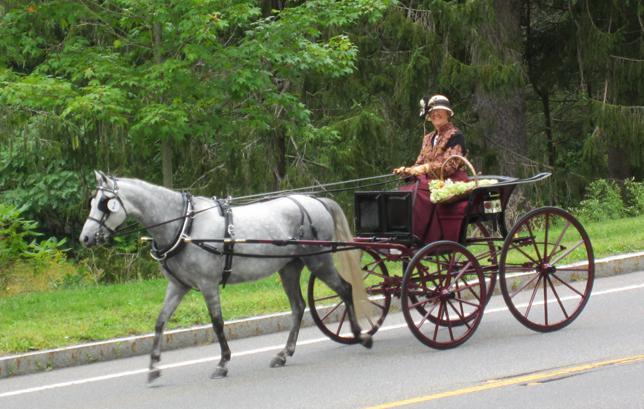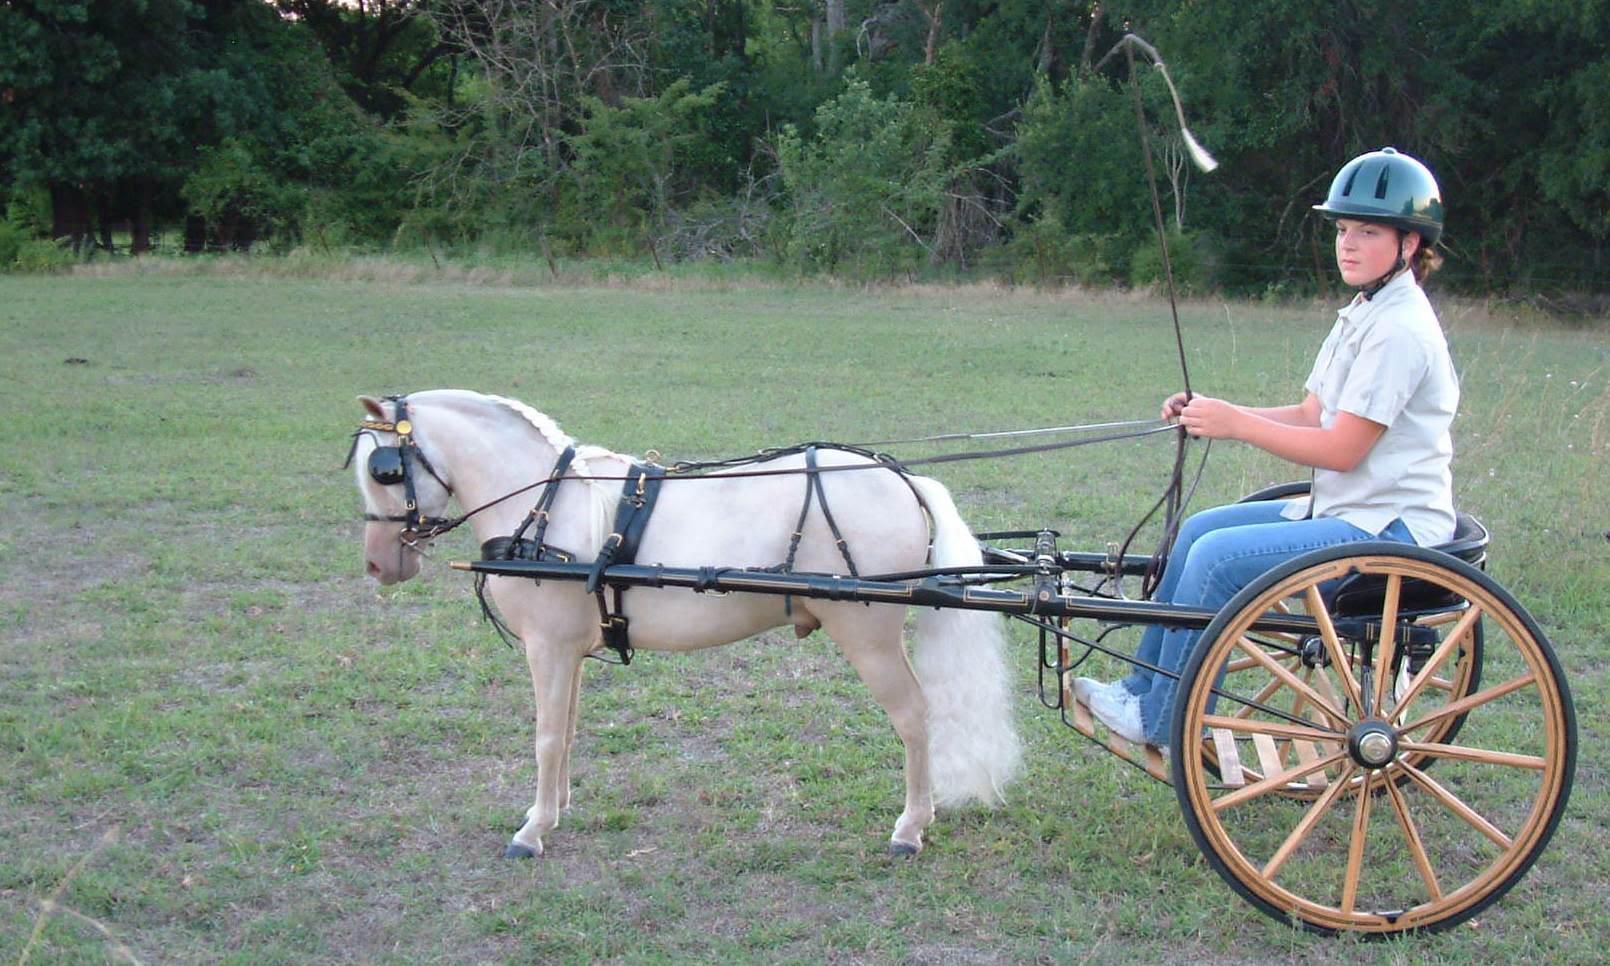The first image is the image on the left, the second image is the image on the right. For the images shown, is this caption "there is at least one pony pulling a cart, there is a man in a blue tshirt and a cowboy hat sitting" true? Answer yes or no. No. The first image is the image on the left, the second image is the image on the right. Given the left and right images, does the statement "One image shows a child in blue jeans without a hat holding out at least one arm while riding a two-wheeled cart pulled across dirt by a pony." hold true? Answer yes or no. No. 